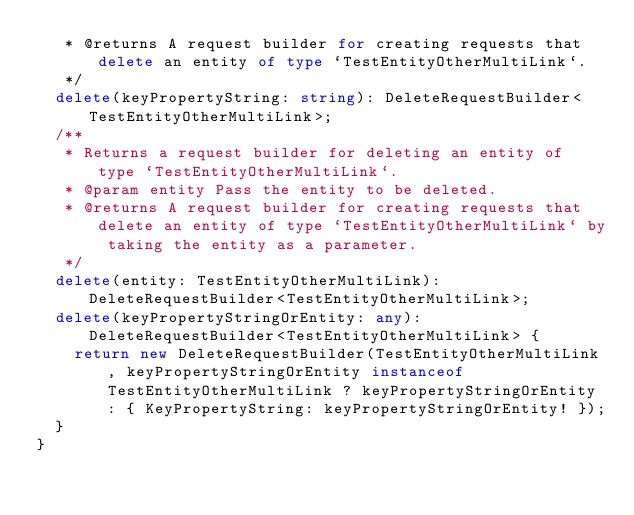Convert code to text. <code><loc_0><loc_0><loc_500><loc_500><_TypeScript_>   * @returns A request builder for creating requests that delete an entity of type `TestEntityOtherMultiLink`.
   */
  delete(keyPropertyString: string): DeleteRequestBuilder<TestEntityOtherMultiLink>;
  /**
   * Returns a request builder for deleting an entity of type `TestEntityOtherMultiLink`.
   * @param entity Pass the entity to be deleted.
   * @returns A request builder for creating requests that delete an entity of type `TestEntityOtherMultiLink` by taking the entity as a parameter.
   */
  delete(entity: TestEntityOtherMultiLink): DeleteRequestBuilder<TestEntityOtherMultiLink>;
  delete(keyPropertyStringOrEntity: any): DeleteRequestBuilder<TestEntityOtherMultiLink> {
    return new DeleteRequestBuilder(TestEntityOtherMultiLink, keyPropertyStringOrEntity instanceof TestEntityOtherMultiLink ? keyPropertyStringOrEntity : { KeyPropertyString: keyPropertyStringOrEntity! });
  }
}
</code> 